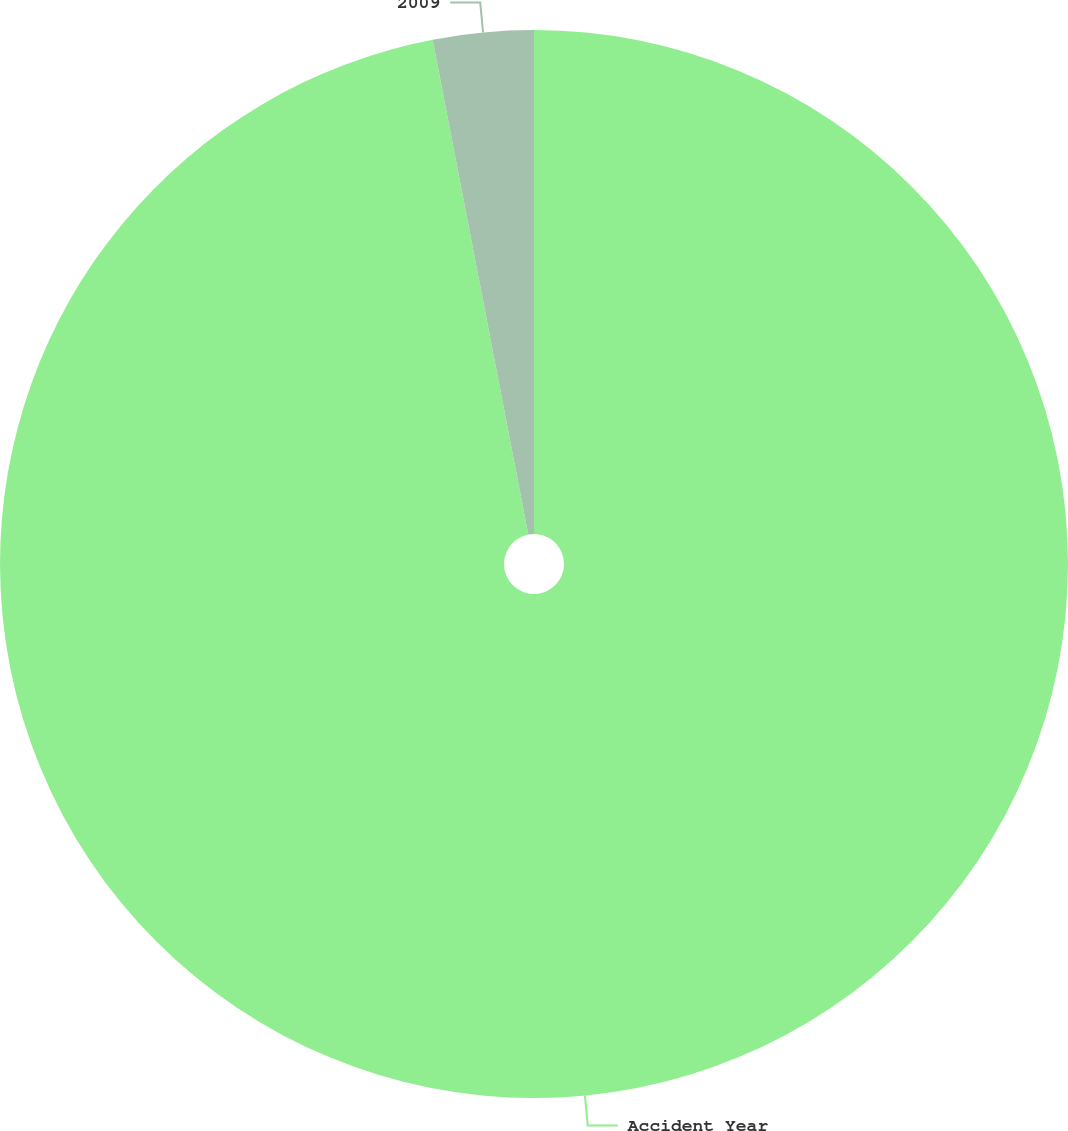Convert chart. <chart><loc_0><loc_0><loc_500><loc_500><pie_chart><fcel>Accident Year<fcel>2009<nl><fcel>96.96%<fcel>3.04%<nl></chart> 